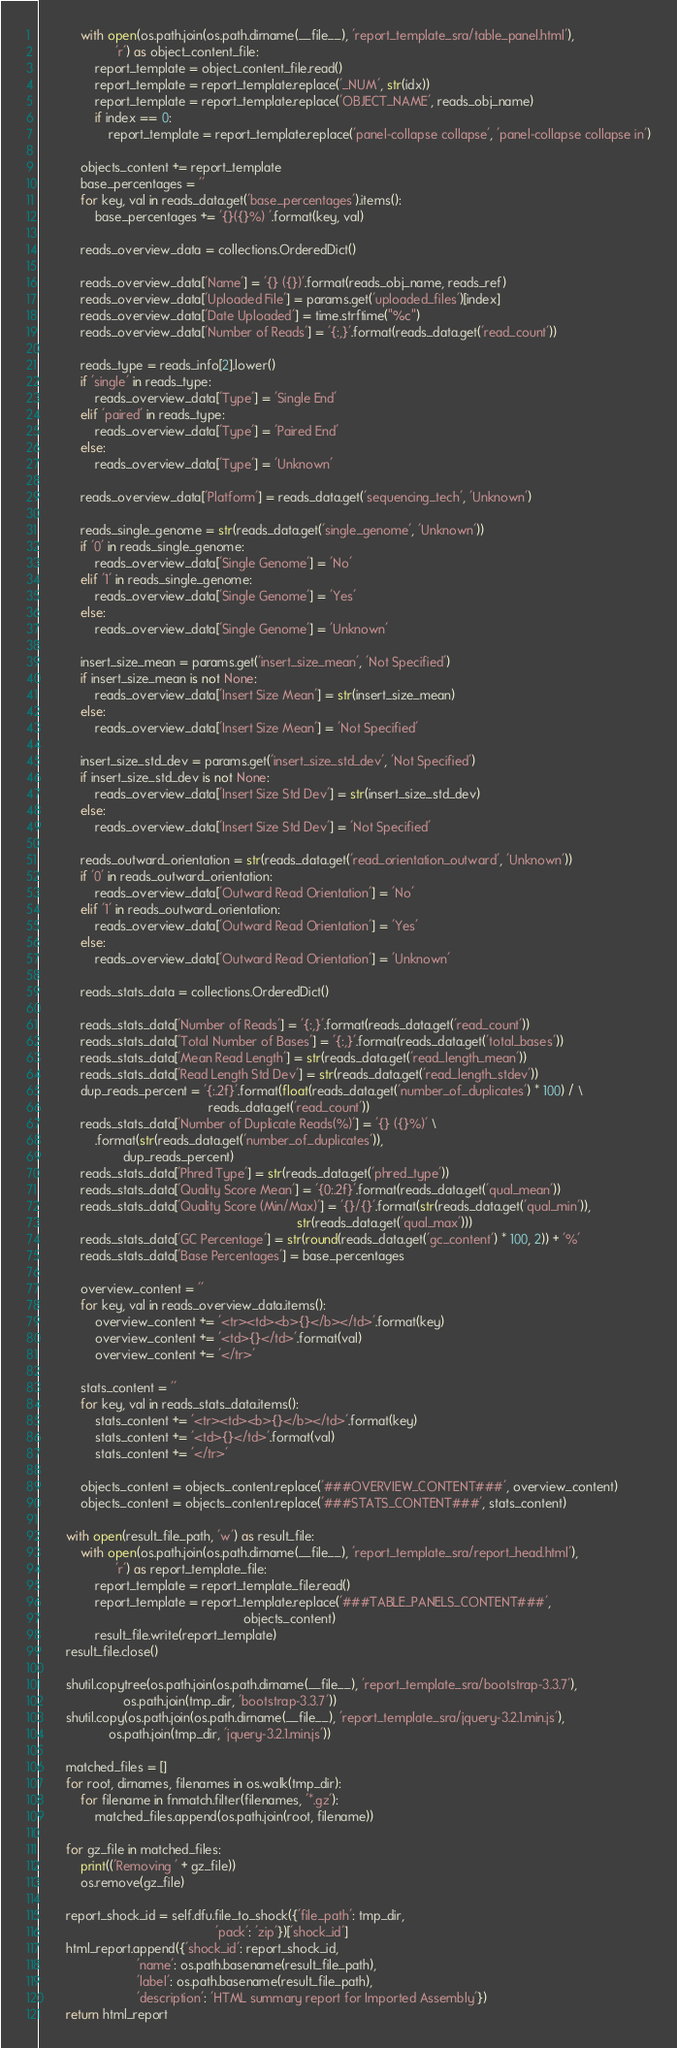Convert code to text. <code><loc_0><loc_0><loc_500><loc_500><_Python_>
            with open(os.path.join(os.path.dirname(__file__), 'report_template_sra/table_panel.html'),
                      'r') as object_content_file:
                report_template = object_content_file.read()
                report_template = report_template.replace('_NUM', str(idx))
                report_template = report_template.replace('OBJECT_NAME', reads_obj_name)
                if index == 0:
                    report_template = report_template.replace('panel-collapse collapse', 'panel-collapse collapse in')

            objects_content += report_template
            base_percentages = ''
            for key, val in reads_data.get('base_percentages').items():
                base_percentages += '{}({}%) '.format(key, val)

            reads_overview_data = collections.OrderedDict()

            reads_overview_data['Name'] = '{} ({})'.format(reads_obj_name, reads_ref)
            reads_overview_data['Uploaded File'] = params.get('uploaded_files')[index]
            reads_overview_data['Date Uploaded'] = time.strftime("%c")
            reads_overview_data['Number of Reads'] = '{:,}'.format(reads_data.get('read_count'))

            reads_type = reads_info[2].lower()
            if 'single' in reads_type:
                reads_overview_data['Type'] = 'Single End'
            elif 'paired' in reads_type:
                reads_overview_data['Type'] = 'Paired End'
            else:
                reads_overview_data['Type'] = 'Unknown'

            reads_overview_data['Platform'] = reads_data.get('sequencing_tech', 'Unknown')

            reads_single_genome = str(reads_data.get('single_genome', 'Unknown'))
            if '0' in reads_single_genome:
                reads_overview_data['Single Genome'] = 'No'
            elif '1' in reads_single_genome:
                reads_overview_data['Single Genome'] = 'Yes'
            else:
                reads_overview_data['Single Genome'] = 'Unknown'

            insert_size_mean = params.get('insert_size_mean', 'Not Specified')
            if insert_size_mean is not None:
                reads_overview_data['Insert Size Mean'] = str(insert_size_mean)
            else:
                reads_overview_data['Insert Size Mean'] = 'Not Specified'

            insert_size_std_dev = params.get('insert_size_std_dev', 'Not Specified')
            if insert_size_std_dev is not None:
                reads_overview_data['Insert Size Std Dev'] = str(insert_size_std_dev)
            else:
                reads_overview_data['Insert Size Std Dev'] = 'Not Specified'

            reads_outward_orientation = str(reads_data.get('read_orientation_outward', 'Unknown'))
            if '0' in reads_outward_orientation:
                reads_overview_data['Outward Read Orientation'] = 'No'
            elif '1' in reads_outward_orientation:
                reads_overview_data['Outward Read Orientation'] = 'Yes'
            else:
                reads_overview_data['Outward Read Orientation'] = 'Unknown'

            reads_stats_data = collections.OrderedDict()

            reads_stats_data['Number of Reads'] = '{:,}'.format(reads_data.get('read_count'))
            reads_stats_data['Total Number of Bases'] = '{:,}'.format(reads_data.get('total_bases'))
            reads_stats_data['Mean Read Length'] = str(reads_data.get('read_length_mean'))
            reads_stats_data['Read Length Std Dev'] = str(reads_data.get('read_length_stdev'))
            dup_reads_percent = '{:.2f}'.format(float(reads_data.get('number_of_duplicates') * 100) / \
                                                reads_data.get('read_count'))
            reads_stats_data['Number of Duplicate Reads(%)'] = '{} ({}%)' \
                .format(str(reads_data.get('number_of_duplicates')),
                        dup_reads_percent)
            reads_stats_data['Phred Type'] = str(reads_data.get('phred_type'))
            reads_stats_data['Quality Score Mean'] = '{0:.2f}'.format(reads_data.get('qual_mean'))
            reads_stats_data['Quality Score (Min/Max)'] = '{}/{}'.format(str(reads_data.get('qual_min')),
                                                                         str(reads_data.get('qual_max')))
            reads_stats_data['GC Percentage'] = str(round(reads_data.get('gc_content') * 100, 2)) + '%'
            reads_stats_data['Base Percentages'] = base_percentages

            overview_content = ''
            for key, val in reads_overview_data.items():
                overview_content += '<tr><td><b>{}</b></td>'.format(key)
                overview_content += '<td>{}</td>'.format(val)
                overview_content += '</tr>'

            stats_content = ''
            for key, val in reads_stats_data.items():
                stats_content += '<tr><td><b>{}</b></td>'.format(key)
                stats_content += '<td>{}</td>'.format(val)
                stats_content += '</tr>'

            objects_content = objects_content.replace('###OVERVIEW_CONTENT###', overview_content)
            objects_content = objects_content.replace('###STATS_CONTENT###', stats_content)

        with open(result_file_path, 'w') as result_file:
            with open(os.path.join(os.path.dirname(__file__), 'report_template_sra/report_head.html'),
                      'r') as report_template_file:
                report_template = report_template_file.read()
                report_template = report_template.replace('###TABLE_PANELS_CONTENT###',
                                                          objects_content)
                result_file.write(report_template)
        result_file.close()

        shutil.copytree(os.path.join(os.path.dirname(__file__), 'report_template_sra/bootstrap-3.3.7'),
                        os.path.join(tmp_dir, 'bootstrap-3.3.7'))
        shutil.copy(os.path.join(os.path.dirname(__file__), 'report_template_sra/jquery-3.2.1.min.js'),
                    os.path.join(tmp_dir, 'jquery-3.2.1.min.js'))

        matched_files = []
        for root, dirnames, filenames in os.walk(tmp_dir):
            for filename in fnmatch.filter(filenames, '*.gz'):
                matched_files.append(os.path.join(root, filename))

        for gz_file in matched_files:
            print(('Removing ' + gz_file))
            os.remove(gz_file)

        report_shock_id = self.dfu.file_to_shock({'file_path': tmp_dir,
                                                  'pack': 'zip'})['shock_id']
        html_report.append({'shock_id': report_shock_id,
                            'name': os.path.basename(result_file_path),
                            'label': os.path.basename(result_file_path),
                            'description': 'HTML summary report for Imported Assembly'})
        return html_report
</code> 